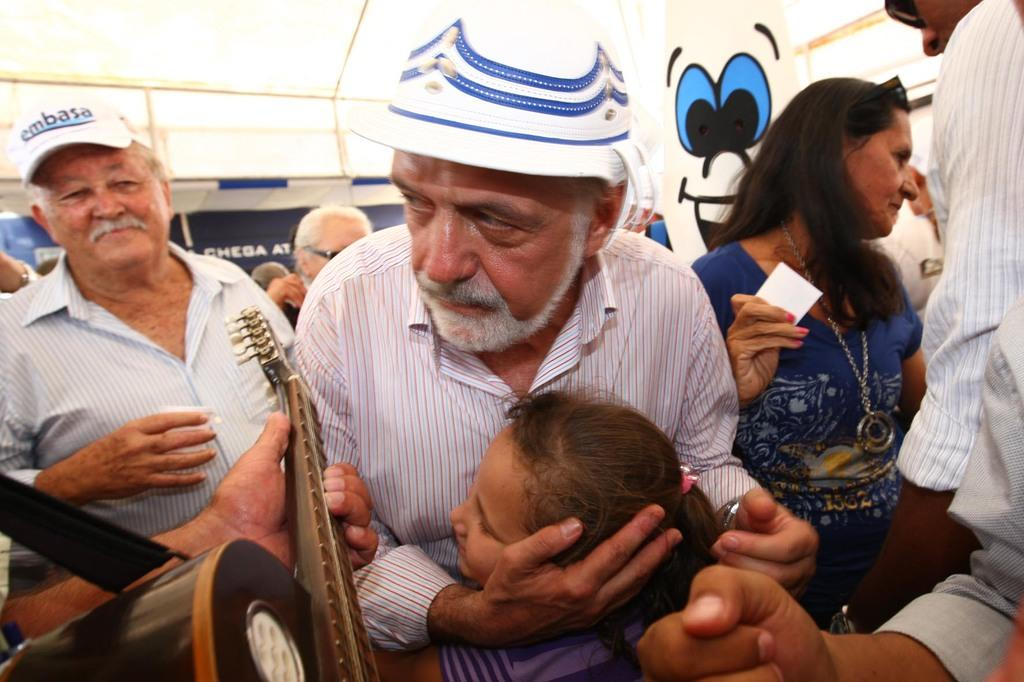Who are the two main subjects in the image? There is a man and a girl in the image. What is the man doing to the girl? The man is hugging the girl. Can you describe the background of the image? There are people in the background of the image. What object can be seen in the bottom left corner of the image? There is a guitar in the bottom left corner of the image. What type of riddle is the girl trying to solve in the image? There is no riddle present in the image; the girl is being hugged by the man. What kind of beast can be seen in the image? There is no beast present in the image; it features a man hugging a girl, people in the background, and a guitar in the corner. 